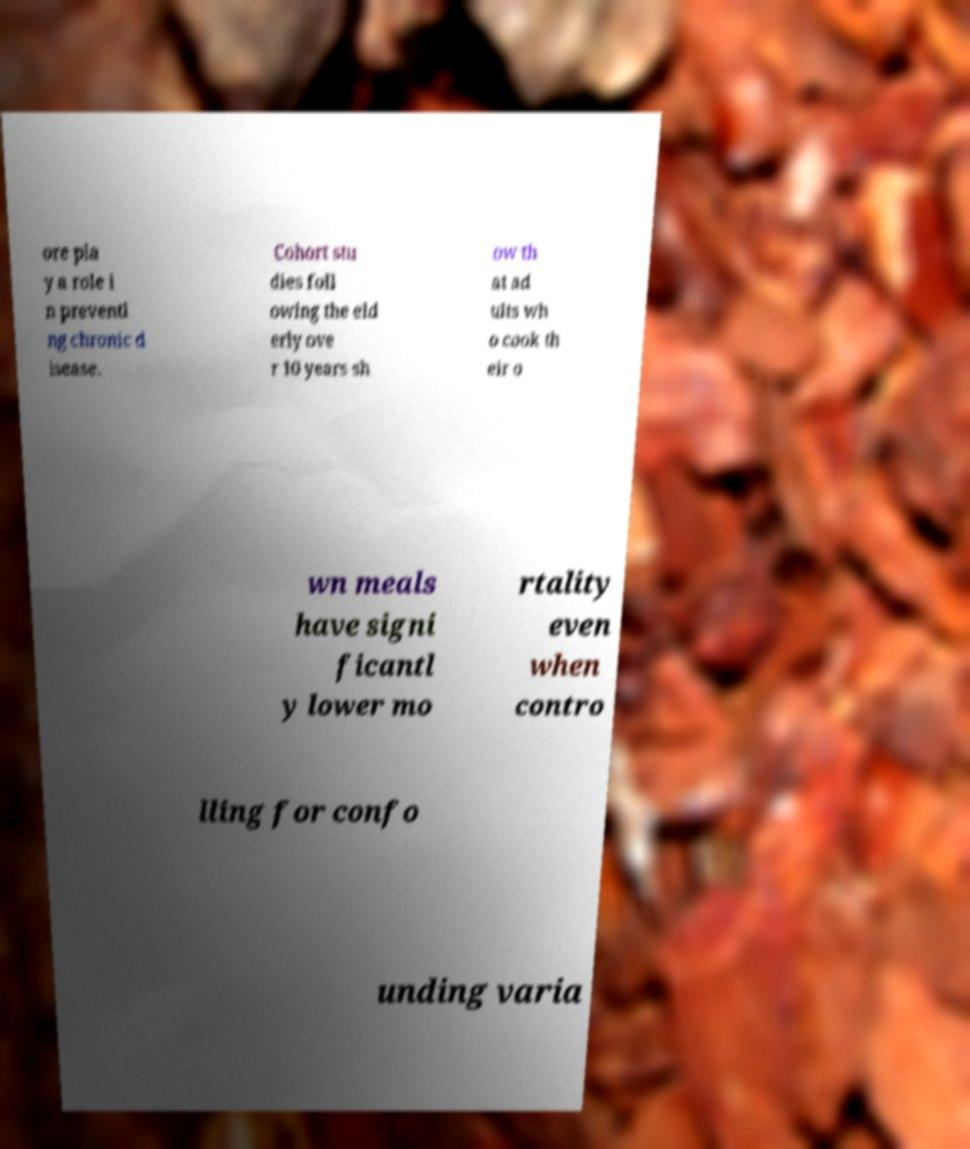There's text embedded in this image that I need extracted. Can you transcribe it verbatim? ore pla y a role i n preventi ng chronic d isease. Cohort stu dies foll owing the eld erly ove r 10 years sh ow th at ad ults wh o cook th eir o wn meals have signi ficantl y lower mo rtality even when contro lling for confo unding varia 